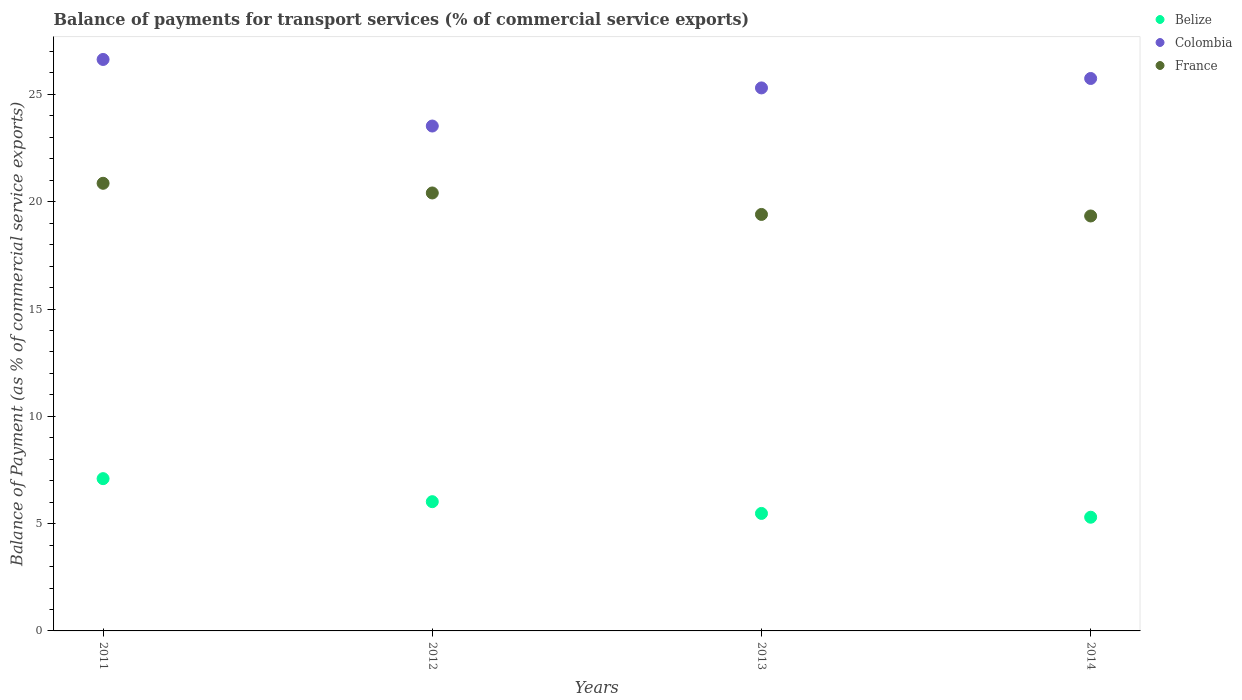How many different coloured dotlines are there?
Your response must be concise. 3. Is the number of dotlines equal to the number of legend labels?
Offer a terse response. Yes. What is the balance of payments for transport services in Colombia in 2012?
Give a very brief answer. 23.53. Across all years, what is the maximum balance of payments for transport services in Colombia?
Keep it short and to the point. 26.63. Across all years, what is the minimum balance of payments for transport services in Colombia?
Provide a succinct answer. 23.53. In which year was the balance of payments for transport services in France maximum?
Provide a short and direct response. 2011. What is the total balance of payments for transport services in France in the graph?
Ensure brevity in your answer.  80.01. What is the difference between the balance of payments for transport services in France in 2011 and that in 2013?
Your answer should be very brief. 1.45. What is the difference between the balance of payments for transport services in Belize in 2011 and the balance of payments for transport services in France in 2014?
Keep it short and to the point. -12.24. What is the average balance of payments for transport services in Colombia per year?
Offer a very short reply. 25.3. In the year 2011, what is the difference between the balance of payments for transport services in France and balance of payments for transport services in Colombia?
Offer a very short reply. -5.77. In how many years, is the balance of payments for transport services in Belize greater than 15 %?
Offer a terse response. 0. What is the ratio of the balance of payments for transport services in France in 2011 to that in 2012?
Ensure brevity in your answer.  1.02. Is the difference between the balance of payments for transport services in France in 2011 and 2013 greater than the difference between the balance of payments for transport services in Colombia in 2011 and 2013?
Keep it short and to the point. Yes. What is the difference between the highest and the second highest balance of payments for transport services in Colombia?
Make the answer very short. 0.89. What is the difference between the highest and the lowest balance of payments for transport services in Colombia?
Your answer should be very brief. 3.1. Is the balance of payments for transport services in Colombia strictly less than the balance of payments for transport services in France over the years?
Your response must be concise. No. How many years are there in the graph?
Give a very brief answer. 4. What is the difference between two consecutive major ticks on the Y-axis?
Ensure brevity in your answer.  5. Does the graph contain any zero values?
Offer a very short reply. No. Where does the legend appear in the graph?
Your response must be concise. Top right. What is the title of the graph?
Offer a terse response. Balance of payments for transport services (% of commercial service exports). Does "Samoa" appear as one of the legend labels in the graph?
Your response must be concise. No. What is the label or title of the X-axis?
Give a very brief answer. Years. What is the label or title of the Y-axis?
Your answer should be compact. Balance of Payment (as % of commercial service exports). What is the Balance of Payment (as % of commercial service exports) of Belize in 2011?
Keep it short and to the point. 7.1. What is the Balance of Payment (as % of commercial service exports) in Colombia in 2011?
Your answer should be very brief. 26.63. What is the Balance of Payment (as % of commercial service exports) of France in 2011?
Your answer should be compact. 20.86. What is the Balance of Payment (as % of commercial service exports) of Belize in 2012?
Your answer should be compact. 6.02. What is the Balance of Payment (as % of commercial service exports) in Colombia in 2012?
Your answer should be compact. 23.53. What is the Balance of Payment (as % of commercial service exports) in France in 2012?
Offer a terse response. 20.41. What is the Balance of Payment (as % of commercial service exports) of Belize in 2013?
Offer a very short reply. 5.48. What is the Balance of Payment (as % of commercial service exports) in Colombia in 2013?
Offer a terse response. 25.3. What is the Balance of Payment (as % of commercial service exports) in France in 2013?
Your response must be concise. 19.41. What is the Balance of Payment (as % of commercial service exports) of Belize in 2014?
Give a very brief answer. 5.3. What is the Balance of Payment (as % of commercial service exports) of Colombia in 2014?
Keep it short and to the point. 25.74. What is the Balance of Payment (as % of commercial service exports) in France in 2014?
Offer a very short reply. 19.34. Across all years, what is the maximum Balance of Payment (as % of commercial service exports) in Belize?
Your answer should be compact. 7.1. Across all years, what is the maximum Balance of Payment (as % of commercial service exports) of Colombia?
Your answer should be compact. 26.63. Across all years, what is the maximum Balance of Payment (as % of commercial service exports) of France?
Ensure brevity in your answer.  20.86. Across all years, what is the minimum Balance of Payment (as % of commercial service exports) in Belize?
Keep it short and to the point. 5.3. Across all years, what is the minimum Balance of Payment (as % of commercial service exports) in Colombia?
Your answer should be very brief. 23.53. Across all years, what is the minimum Balance of Payment (as % of commercial service exports) in France?
Give a very brief answer. 19.34. What is the total Balance of Payment (as % of commercial service exports) in Belize in the graph?
Keep it short and to the point. 23.89. What is the total Balance of Payment (as % of commercial service exports) of Colombia in the graph?
Offer a very short reply. 101.21. What is the total Balance of Payment (as % of commercial service exports) of France in the graph?
Keep it short and to the point. 80.01. What is the difference between the Balance of Payment (as % of commercial service exports) of Belize in 2011 and that in 2012?
Keep it short and to the point. 1.07. What is the difference between the Balance of Payment (as % of commercial service exports) of Colombia in 2011 and that in 2012?
Make the answer very short. 3.1. What is the difference between the Balance of Payment (as % of commercial service exports) in France in 2011 and that in 2012?
Give a very brief answer. 0.45. What is the difference between the Balance of Payment (as % of commercial service exports) of Belize in 2011 and that in 2013?
Your answer should be compact. 1.62. What is the difference between the Balance of Payment (as % of commercial service exports) in Colombia in 2011 and that in 2013?
Provide a short and direct response. 1.33. What is the difference between the Balance of Payment (as % of commercial service exports) of France in 2011 and that in 2013?
Your response must be concise. 1.45. What is the difference between the Balance of Payment (as % of commercial service exports) in Belize in 2011 and that in 2014?
Ensure brevity in your answer.  1.8. What is the difference between the Balance of Payment (as % of commercial service exports) in Colombia in 2011 and that in 2014?
Give a very brief answer. 0.89. What is the difference between the Balance of Payment (as % of commercial service exports) of France in 2011 and that in 2014?
Your answer should be very brief. 1.52. What is the difference between the Balance of Payment (as % of commercial service exports) of Belize in 2012 and that in 2013?
Give a very brief answer. 0.55. What is the difference between the Balance of Payment (as % of commercial service exports) in Colombia in 2012 and that in 2013?
Provide a short and direct response. -1.78. What is the difference between the Balance of Payment (as % of commercial service exports) of Belize in 2012 and that in 2014?
Offer a terse response. 0.72. What is the difference between the Balance of Payment (as % of commercial service exports) of Colombia in 2012 and that in 2014?
Give a very brief answer. -2.22. What is the difference between the Balance of Payment (as % of commercial service exports) of France in 2012 and that in 2014?
Your answer should be very brief. 1.07. What is the difference between the Balance of Payment (as % of commercial service exports) of Belize in 2013 and that in 2014?
Your response must be concise. 0.18. What is the difference between the Balance of Payment (as % of commercial service exports) in Colombia in 2013 and that in 2014?
Your answer should be compact. -0.44. What is the difference between the Balance of Payment (as % of commercial service exports) of France in 2013 and that in 2014?
Your answer should be compact. 0.07. What is the difference between the Balance of Payment (as % of commercial service exports) of Belize in 2011 and the Balance of Payment (as % of commercial service exports) of Colombia in 2012?
Your answer should be compact. -16.43. What is the difference between the Balance of Payment (as % of commercial service exports) in Belize in 2011 and the Balance of Payment (as % of commercial service exports) in France in 2012?
Offer a very short reply. -13.31. What is the difference between the Balance of Payment (as % of commercial service exports) in Colombia in 2011 and the Balance of Payment (as % of commercial service exports) in France in 2012?
Keep it short and to the point. 6.22. What is the difference between the Balance of Payment (as % of commercial service exports) of Belize in 2011 and the Balance of Payment (as % of commercial service exports) of Colombia in 2013?
Give a very brief answer. -18.21. What is the difference between the Balance of Payment (as % of commercial service exports) in Belize in 2011 and the Balance of Payment (as % of commercial service exports) in France in 2013?
Offer a very short reply. -12.31. What is the difference between the Balance of Payment (as % of commercial service exports) of Colombia in 2011 and the Balance of Payment (as % of commercial service exports) of France in 2013?
Offer a very short reply. 7.22. What is the difference between the Balance of Payment (as % of commercial service exports) in Belize in 2011 and the Balance of Payment (as % of commercial service exports) in Colombia in 2014?
Provide a short and direct response. -18.65. What is the difference between the Balance of Payment (as % of commercial service exports) in Belize in 2011 and the Balance of Payment (as % of commercial service exports) in France in 2014?
Offer a very short reply. -12.24. What is the difference between the Balance of Payment (as % of commercial service exports) in Colombia in 2011 and the Balance of Payment (as % of commercial service exports) in France in 2014?
Your answer should be compact. 7.29. What is the difference between the Balance of Payment (as % of commercial service exports) of Belize in 2012 and the Balance of Payment (as % of commercial service exports) of Colombia in 2013?
Your answer should be very brief. -19.28. What is the difference between the Balance of Payment (as % of commercial service exports) in Belize in 2012 and the Balance of Payment (as % of commercial service exports) in France in 2013?
Keep it short and to the point. -13.39. What is the difference between the Balance of Payment (as % of commercial service exports) in Colombia in 2012 and the Balance of Payment (as % of commercial service exports) in France in 2013?
Your answer should be very brief. 4.12. What is the difference between the Balance of Payment (as % of commercial service exports) in Belize in 2012 and the Balance of Payment (as % of commercial service exports) in Colombia in 2014?
Keep it short and to the point. -19.72. What is the difference between the Balance of Payment (as % of commercial service exports) in Belize in 2012 and the Balance of Payment (as % of commercial service exports) in France in 2014?
Your response must be concise. -13.31. What is the difference between the Balance of Payment (as % of commercial service exports) in Colombia in 2012 and the Balance of Payment (as % of commercial service exports) in France in 2014?
Provide a succinct answer. 4.19. What is the difference between the Balance of Payment (as % of commercial service exports) in Belize in 2013 and the Balance of Payment (as % of commercial service exports) in Colombia in 2014?
Give a very brief answer. -20.27. What is the difference between the Balance of Payment (as % of commercial service exports) in Belize in 2013 and the Balance of Payment (as % of commercial service exports) in France in 2014?
Keep it short and to the point. -13.86. What is the difference between the Balance of Payment (as % of commercial service exports) in Colombia in 2013 and the Balance of Payment (as % of commercial service exports) in France in 2014?
Offer a very short reply. 5.97. What is the average Balance of Payment (as % of commercial service exports) of Belize per year?
Provide a short and direct response. 5.97. What is the average Balance of Payment (as % of commercial service exports) in Colombia per year?
Offer a terse response. 25.3. What is the average Balance of Payment (as % of commercial service exports) in France per year?
Keep it short and to the point. 20. In the year 2011, what is the difference between the Balance of Payment (as % of commercial service exports) in Belize and Balance of Payment (as % of commercial service exports) in Colombia?
Your answer should be very brief. -19.53. In the year 2011, what is the difference between the Balance of Payment (as % of commercial service exports) in Belize and Balance of Payment (as % of commercial service exports) in France?
Offer a very short reply. -13.76. In the year 2011, what is the difference between the Balance of Payment (as % of commercial service exports) in Colombia and Balance of Payment (as % of commercial service exports) in France?
Your answer should be compact. 5.77. In the year 2012, what is the difference between the Balance of Payment (as % of commercial service exports) in Belize and Balance of Payment (as % of commercial service exports) in Colombia?
Make the answer very short. -17.51. In the year 2012, what is the difference between the Balance of Payment (as % of commercial service exports) of Belize and Balance of Payment (as % of commercial service exports) of France?
Keep it short and to the point. -14.39. In the year 2012, what is the difference between the Balance of Payment (as % of commercial service exports) in Colombia and Balance of Payment (as % of commercial service exports) in France?
Ensure brevity in your answer.  3.12. In the year 2013, what is the difference between the Balance of Payment (as % of commercial service exports) of Belize and Balance of Payment (as % of commercial service exports) of Colombia?
Provide a short and direct response. -19.83. In the year 2013, what is the difference between the Balance of Payment (as % of commercial service exports) of Belize and Balance of Payment (as % of commercial service exports) of France?
Your answer should be compact. -13.93. In the year 2013, what is the difference between the Balance of Payment (as % of commercial service exports) in Colombia and Balance of Payment (as % of commercial service exports) in France?
Give a very brief answer. 5.9. In the year 2014, what is the difference between the Balance of Payment (as % of commercial service exports) of Belize and Balance of Payment (as % of commercial service exports) of Colombia?
Give a very brief answer. -20.45. In the year 2014, what is the difference between the Balance of Payment (as % of commercial service exports) in Belize and Balance of Payment (as % of commercial service exports) in France?
Make the answer very short. -14.04. In the year 2014, what is the difference between the Balance of Payment (as % of commercial service exports) in Colombia and Balance of Payment (as % of commercial service exports) in France?
Your answer should be very brief. 6.41. What is the ratio of the Balance of Payment (as % of commercial service exports) of Belize in 2011 to that in 2012?
Your answer should be very brief. 1.18. What is the ratio of the Balance of Payment (as % of commercial service exports) in Colombia in 2011 to that in 2012?
Keep it short and to the point. 1.13. What is the ratio of the Balance of Payment (as % of commercial service exports) of France in 2011 to that in 2012?
Offer a very short reply. 1.02. What is the ratio of the Balance of Payment (as % of commercial service exports) of Belize in 2011 to that in 2013?
Offer a terse response. 1.3. What is the ratio of the Balance of Payment (as % of commercial service exports) of Colombia in 2011 to that in 2013?
Ensure brevity in your answer.  1.05. What is the ratio of the Balance of Payment (as % of commercial service exports) in France in 2011 to that in 2013?
Your answer should be very brief. 1.07. What is the ratio of the Balance of Payment (as % of commercial service exports) in Belize in 2011 to that in 2014?
Ensure brevity in your answer.  1.34. What is the ratio of the Balance of Payment (as % of commercial service exports) of Colombia in 2011 to that in 2014?
Provide a succinct answer. 1.03. What is the ratio of the Balance of Payment (as % of commercial service exports) in France in 2011 to that in 2014?
Keep it short and to the point. 1.08. What is the ratio of the Balance of Payment (as % of commercial service exports) of Belize in 2012 to that in 2013?
Keep it short and to the point. 1.1. What is the ratio of the Balance of Payment (as % of commercial service exports) of Colombia in 2012 to that in 2013?
Your response must be concise. 0.93. What is the ratio of the Balance of Payment (as % of commercial service exports) of France in 2012 to that in 2013?
Ensure brevity in your answer.  1.05. What is the ratio of the Balance of Payment (as % of commercial service exports) in Belize in 2012 to that in 2014?
Keep it short and to the point. 1.14. What is the ratio of the Balance of Payment (as % of commercial service exports) in Colombia in 2012 to that in 2014?
Your answer should be very brief. 0.91. What is the ratio of the Balance of Payment (as % of commercial service exports) of France in 2012 to that in 2014?
Offer a terse response. 1.06. What is the ratio of the Balance of Payment (as % of commercial service exports) in Belize in 2013 to that in 2014?
Your answer should be very brief. 1.03. What is the ratio of the Balance of Payment (as % of commercial service exports) of Colombia in 2013 to that in 2014?
Your answer should be very brief. 0.98. What is the difference between the highest and the second highest Balance of Payment (as % of commercial service exports) in Belize?
Provide a succinct answer. 1.07. What is the difference between the highest and the second highest Balance of Payment (as % of commercial service exports) of Colombia?
Make the answer very short. 0.89. What is the difference between the highest and the second highest Balance of Payment (as % of commercial service exports) of France?
Give a very brief answer. 0.45. What is the difference between the highest and the lowest Balance of Payment (as % of commercial service exports) of Belize?
Your answer should be compact. 1.8. What is the difference between the highest and the lowest Balance of Payment (as % of commercial service exports) of Colombia?
Make the answer very short. 3.1. What is the difference between the highest and the lowest Balance of Payment (as % of commercial service exports) of France?
Offer a very short reply. 1.52. 